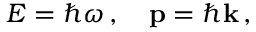<formula> <loc_0><loc_0><loc_500><loc_500>E = \hbar { \omega } \, , \quad p = \hbar { k } \, ,</formula> 